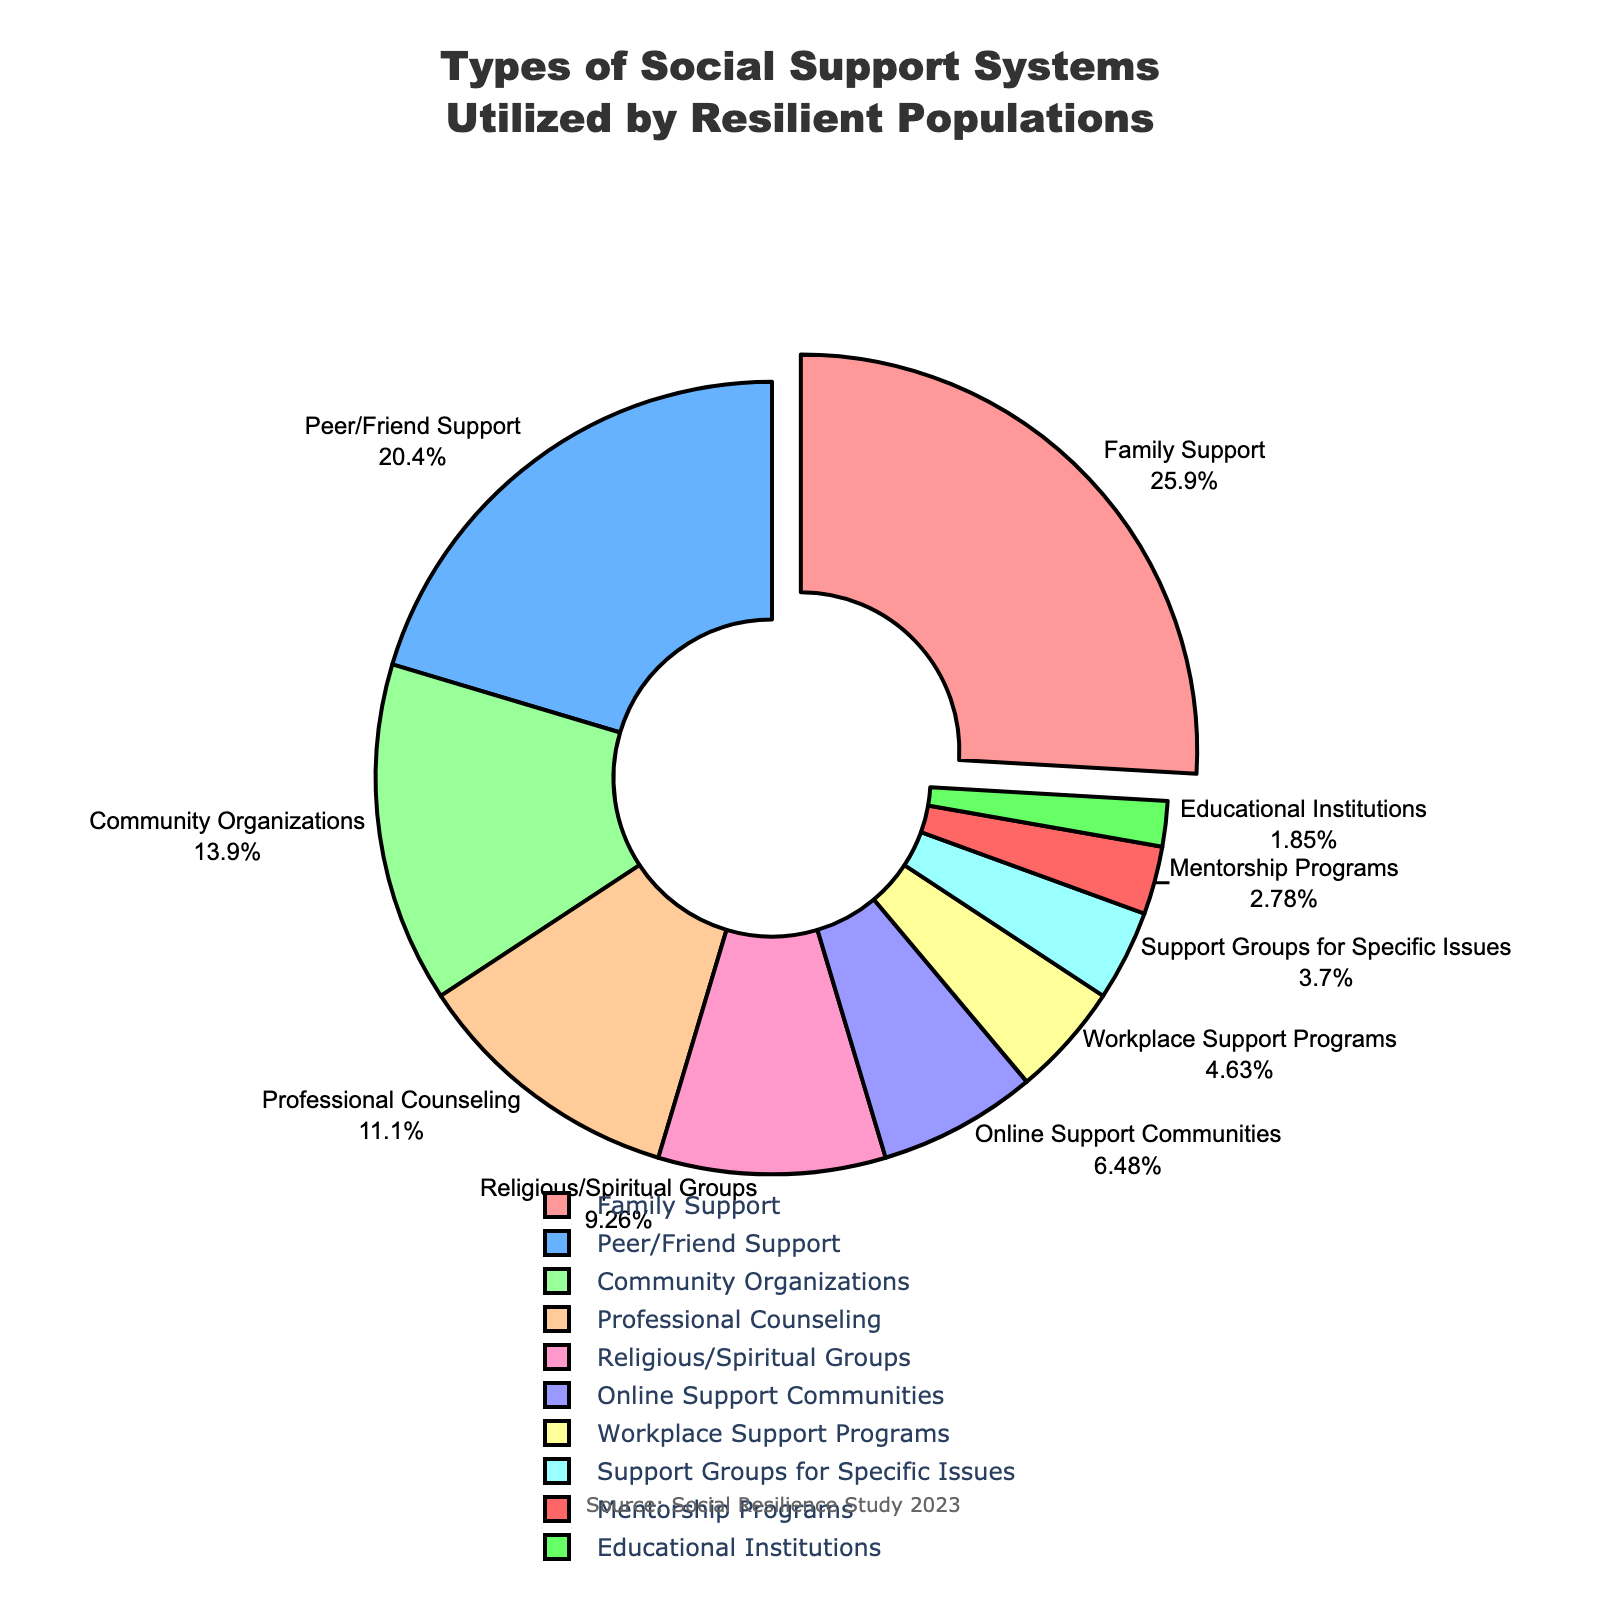what percentage of resilient populations utilize work-related support systems including both Workplace Support Programs and Mentorship Programs? To find this, we need to sum the percentages of Workplace Support Programs (5%) and Mentorship Programs (3%). Therefore, the total percentage is 5 + 3 = 8%.
Answer: 8% which type of social support is utilized the least by resilient populations? The type of social support with the smallest percentage is Educational Institutions, which has a percentage of 2%.
Answer: Educational Institutions how much greater is the percentage of Family Support compared to Professional Counseling? To find this, we subtract the percentage of Professional Counseling (12%) from the percentage of Family Support (28%). Therefore, 28 - 12 = 16%.
Answer: 16% which type of support has the highest percentage, and what is its value? The type of support with the highest percentage is Family Support, which has a value of 28%.
Answer: Family Support, 28% compare the combined percentage of Community Organizations and Peer/Friend Support with Family Support. which one is higher and by how much? First, sum the percentages of Community Organizations (15%) and Peer/Friend Support (22%), which is 15 + 22 = 37%. Family Support has a percentage of 28%. Thus, 37% - 28% = 9%, meaning the combined percentage of Community Organizations and Peer/Friend Support is higher by 9%.
Answer: Community Organizations and Peer/Friend Support, higher by 9% which supports have a percentage close to the value of Family Support? Peer/Friend Support is closest with a percentage of 22%, although it is still 6% less than Family Support.
Answer: Peer/Friend Support, 22% is there a significant visual difference between the slices representing Online Support Communities and Support Groups for Specific Issues? Yes, Online Support Communities have a percentage of 7% and Support Groups for Specific Issues have a percentage of 4%, making Online Support 3% larger. Visually, this difference is noticeable due to the relative size of the slices.
Answer: Yes, Online Support is 3% larger if you added Religious/Spiritual Groups and Educational Institutions' percentages, what would be their combined contribution to resilient populations? The combined contribution is the sum of Religious/Spiritual Groups (10%) and Educational Institutions (2%), which equals 10 + 2 = 12%.
Answer: 12% what color represents Online Support Communities, and how can it be easily identified in the pie chart? Online Support Communities is represented by the color closer to green-ish tones among the palette. It is easily identified by looking for the smallest slice among the pie chart's colors.
Answer: green-ish 